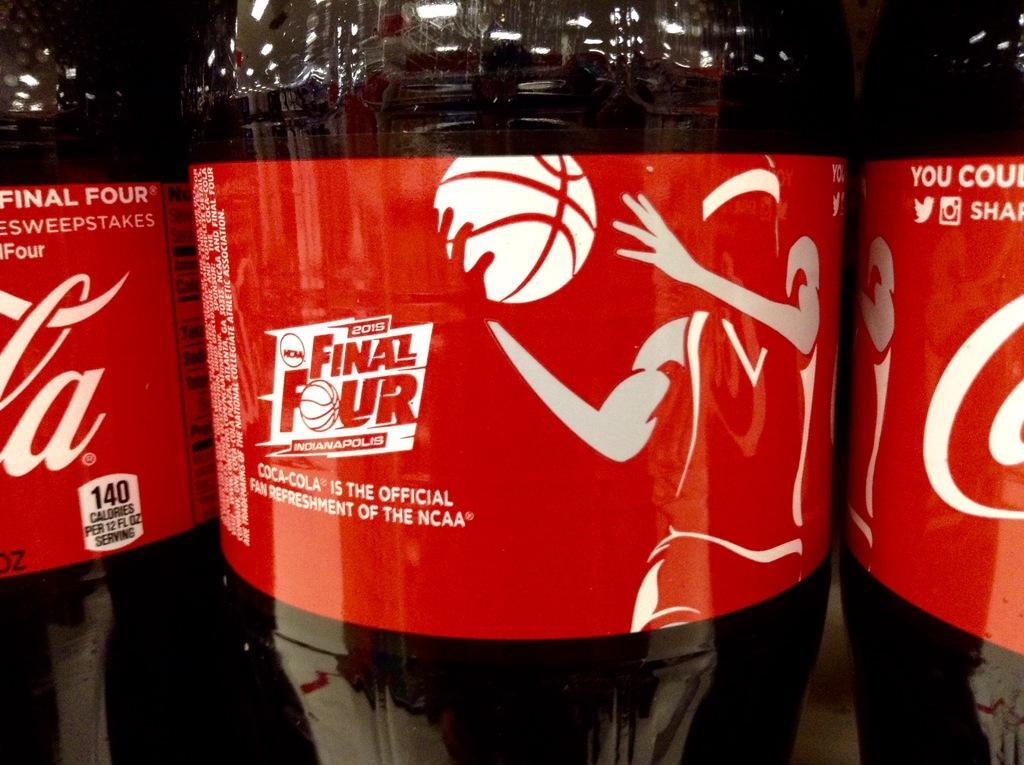How would you summarize this image in a sentence or two? In this picture we can see three bottles with coca cola stickers to it and we have drink in that bottles and on sticker we can see a person holding ball. 